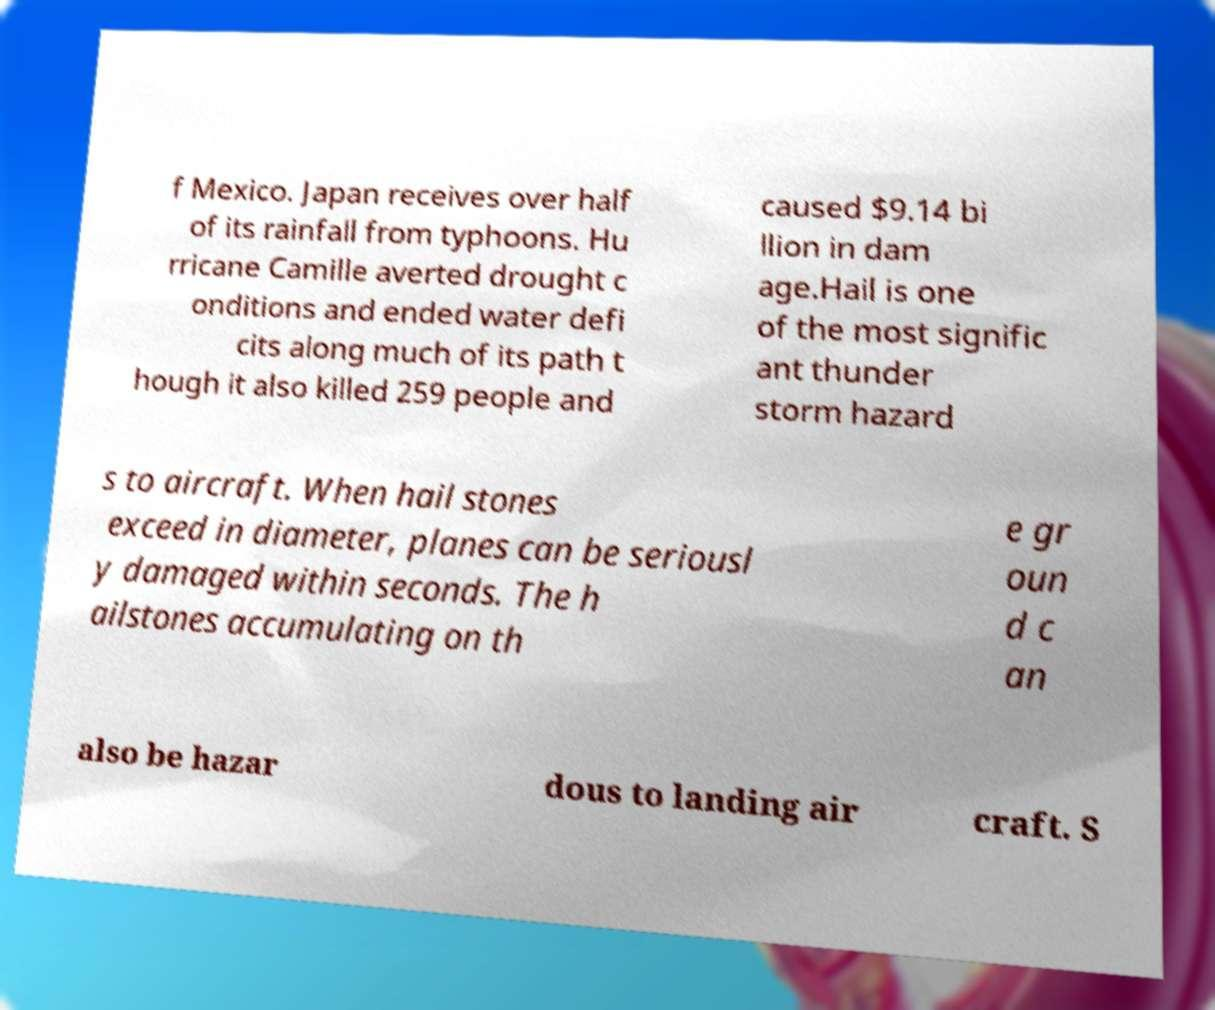Could you assist in decoding the text presented in this image and type it out clearly? f Mexico. Japan receives over half of its rainfall from typhoons. Hu rricane Camille averted drought c onditions and ended water defi cits along much of its path t hough it also killed 259 people and caused $9.14 bi llion in dam age.Hail is one of the most signific ant thunder storm hazard s to aircraft. When hail stones exceed in diameter, planes can be seriousl y damaged within seconds. The h ailstones accumulating on th e gr oun d c an also be hazar dous to landing air craft. S 